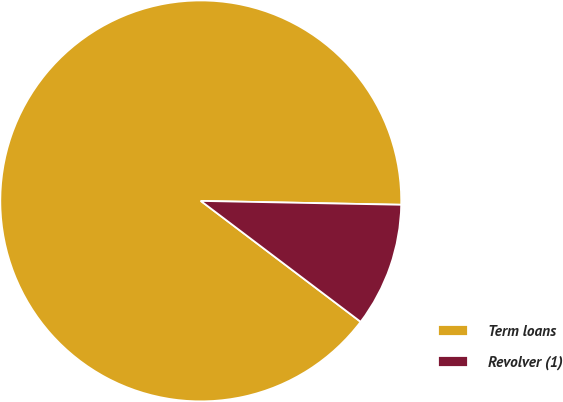Convert chart to OTSL. <chart><loc_0><loc_0><loc_500><loc_500><pie_chart><fcel>Term loans<fcel>Revolver (1)<nl><fcel>90.0%<fcel>10.0%<nl></chart> 